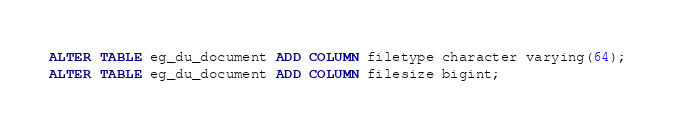Convert code to text. <code><loc_0><loc_0><loc_500><loc_500><_SQL_>ALTER TABLE eg_du_document ADD COLUMN filetype character varying(64);
ALTER TABLE eg_du_document ADD COLUMN filesize bigint;</code> 